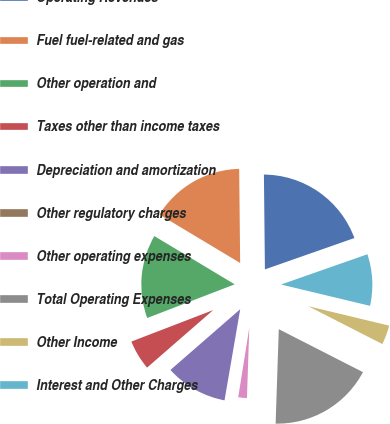<chart> <loc_0><loc_0><loc_500><loc_500><pie_chart><fcel>Operating Revenues<fcel>Fuel fuel-related and gas<fcel>Other operation and<fcel>Taxes other than income taxes<fcel>Depreciation and amortization<fcel>Other regulatory charges<fcel>Other operating expenses<fcel>Total Operating Expenses<fcel>Other Income<fcel>Interest and Other Charges<nl><fcel>19.8%<fcel>16.23%<fcel>14.45%<fcel>5.55%<fcel>10.89%<fcel>0.2%<fcel>1.98%<fcel>18.02%<fcel>3.77%<fcel>9.11%<nl></chart> 